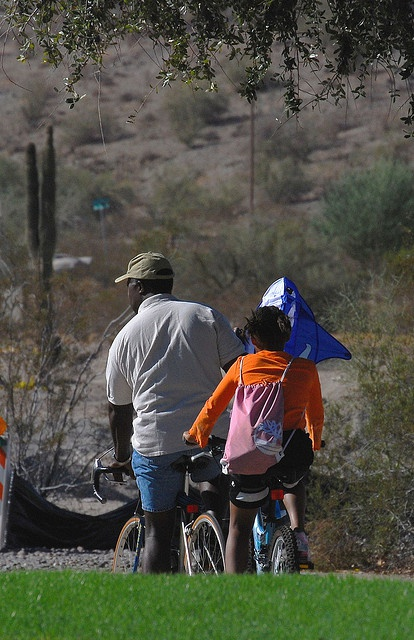Describe the objects in this image and their specific colors. I can see people in gray, black, darkgray, and lightgray tones, people in gray, black, maroon, and red tones, bicycle in gray, black, darkgray, and white tones, backpack in gray, maroon, black, and lightpink tones, and kite in gray, navy, black, and white tones in this image. 